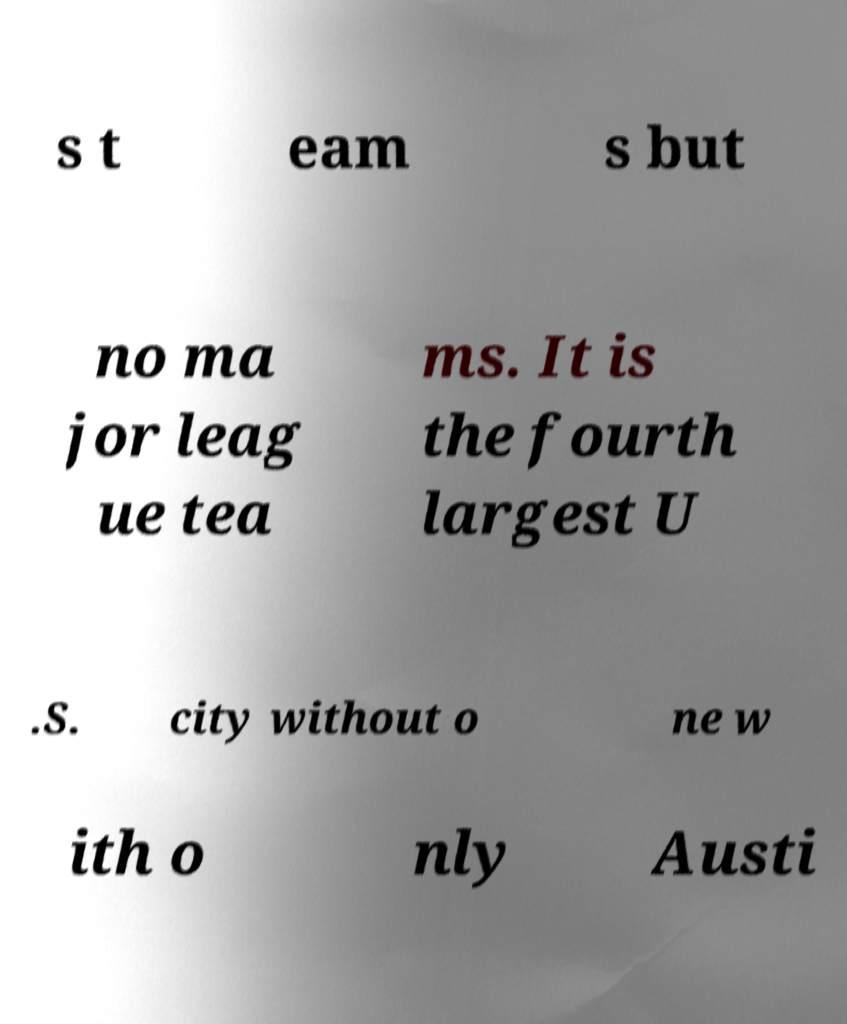There's text embedded in this image that I need extracted. Can you transcribe it verbatim? s t eam s but no ma jor leag ue tea ms. It is the fourth largest U .S. city without o ne w ith o nly Austi 